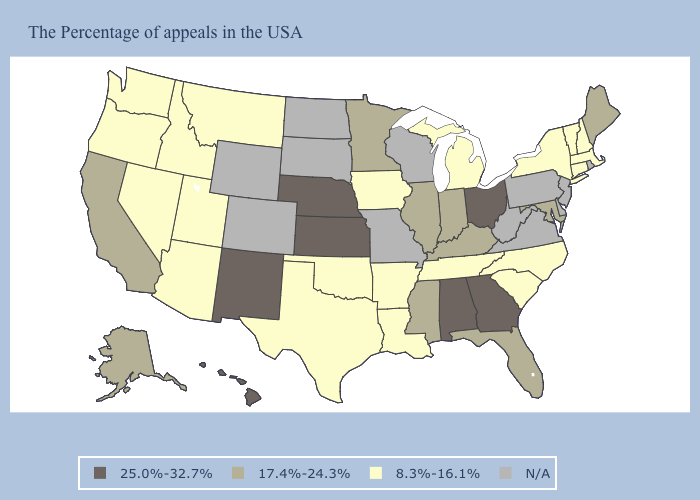Does Alabama have the lowest value in the South?
Give a very brief answer. No. Among the states that border North Carolina , which have the highest value?
Be succinct. Georgia. Which states have the lowest value in the USA?
Keep it brief. Massachusetts, New Hampshire, Vermont, Connecticut, New York, North Carolina, South Carolina, Michigan, Tennessee, Louisiana, Arkansas, Iowa, Oklahoma, Texas, Utah, Montana, Arizona, Idaho, Nevada, Washington, Oregon. Does New Mexico have the highest value in the USA?
Quick response, please. Yes. Which states have the lowest value in the USA?
Give a very brief answer. Massachusetts, New Hampshire, Vermont, Connecticut, New York, North Carolina, South Carolina, Michigan, Tennessee, Louisiana, Arkansas, Iowa, Oklahoma, Texas, Utah, Montana, Arizona, Idaho, Nevada, Washington, Oregon. Does Vermont have the highest value in the Northeast?
Keep it brief. No. What is the value of Montana?
Keep it brief. 8.3%-16.1%. What is the value of North Dakota?
Short answer required. N/A. Does Massachusetts have the highest value in the Northeast?
Quick response, please. No. Name the states that have a value in the range 8.3%-16.1%?
Keep it brief. Massachusetts, New Hampshire, Vermont, Connecticut, New York, North Carolina, South Carolina, Michigan, Tennessee, Louisiana, Arkansas, Iowa, Oklahoma, Texas, Utah, Montana, Arizona, Idaho, Nevada, Washington, Oregon. Among the states that border West Virginia , which have the highest value?
Short answer required. Ohio. What is the lowest value in the USA?
Answer briefly. 8.3%-16.1%. 